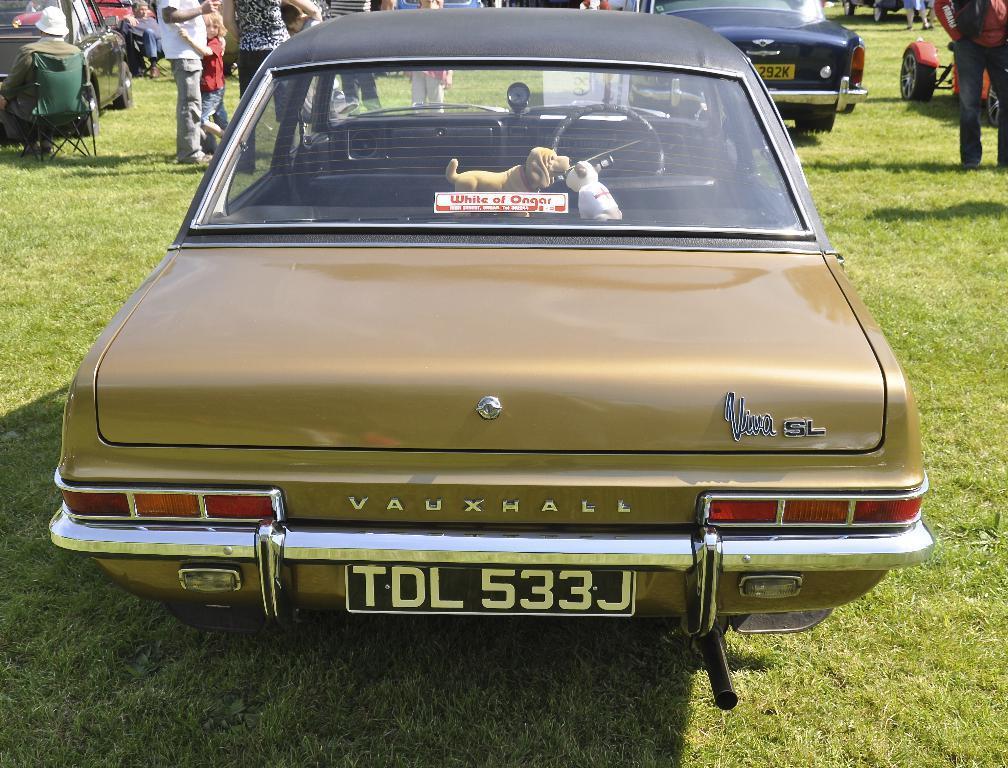In one or two sentences, can you explain what this image depicts? In this image we can see some cars and some persons standing at the foreground of the image there is a car which is of brown color and at the background of the image there is grass. 